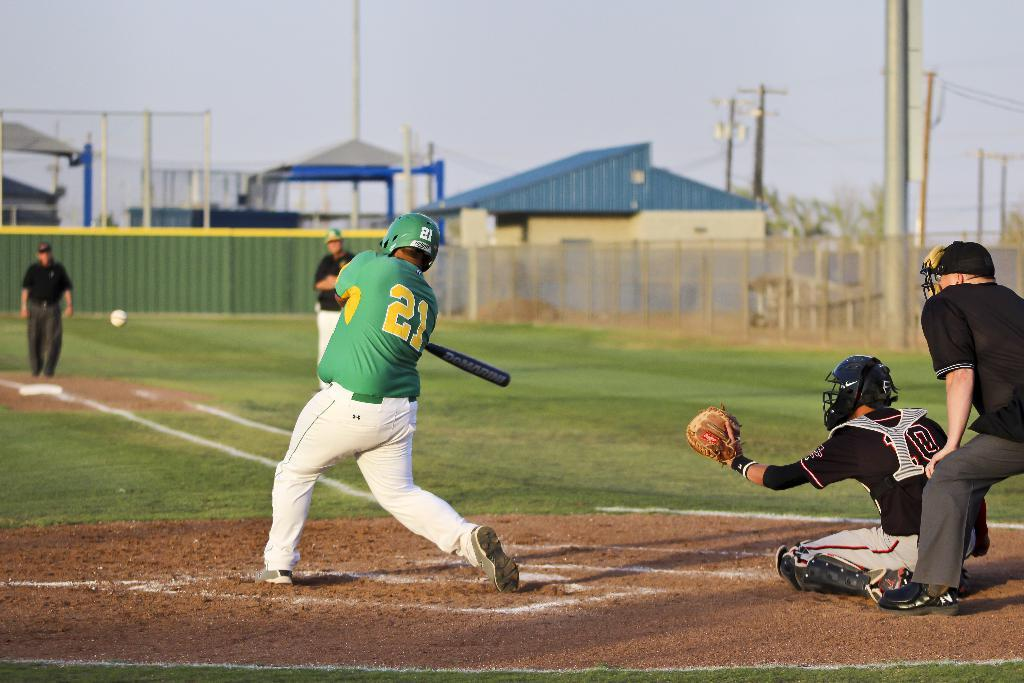<image>
Create a compact narrative representing the image presented. A baseball pitcher who is wearing a shirt with a yellow number 21 on the back. 